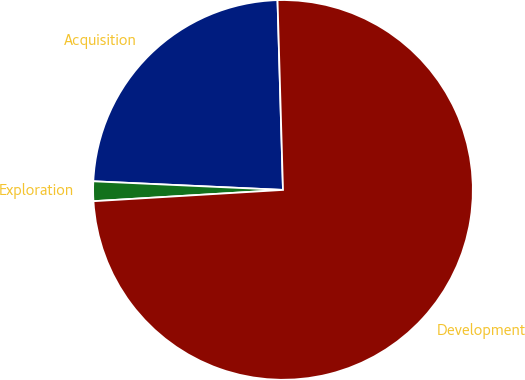Convert chart. <chart><loc_0><loc_0><loc_500><loc_500><pie_chart><fcel>Acquisition<fcel>Exploration<fcel>Development<nl><fcel>23.82%<fcel>1.67%<fcel>74.52%<nl></chart> 